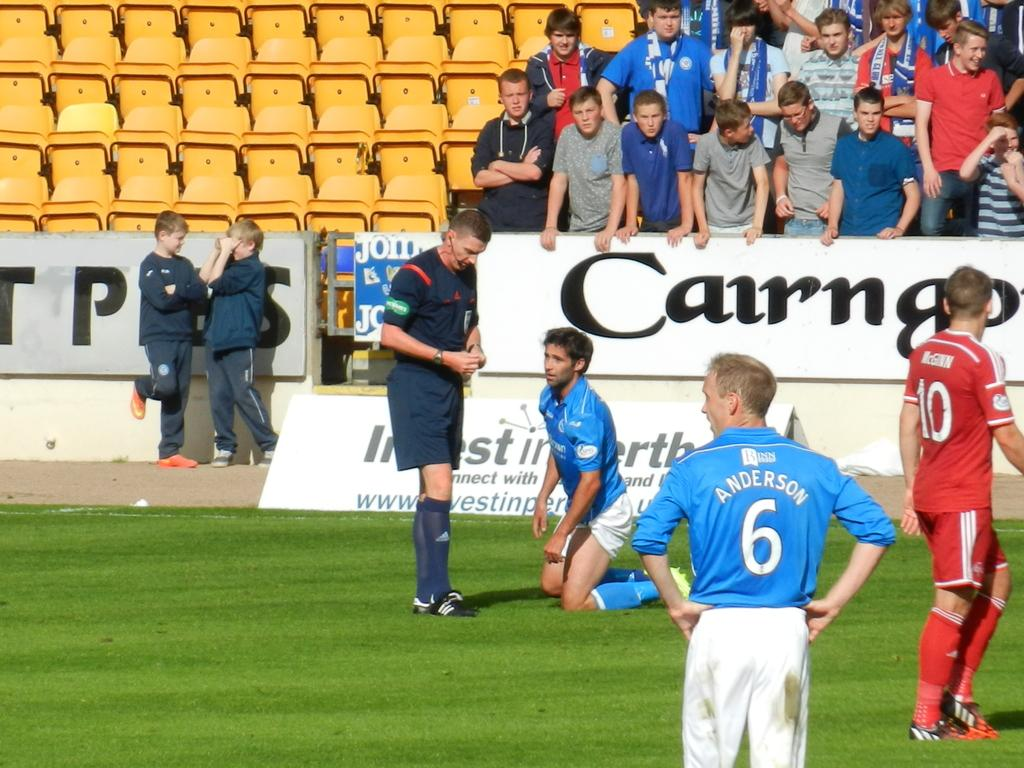<image>
Summarize the visual content of the image. Athlete in a blue shirt with white shorts kneeling in front of the banner Cairngo in black lettering. 